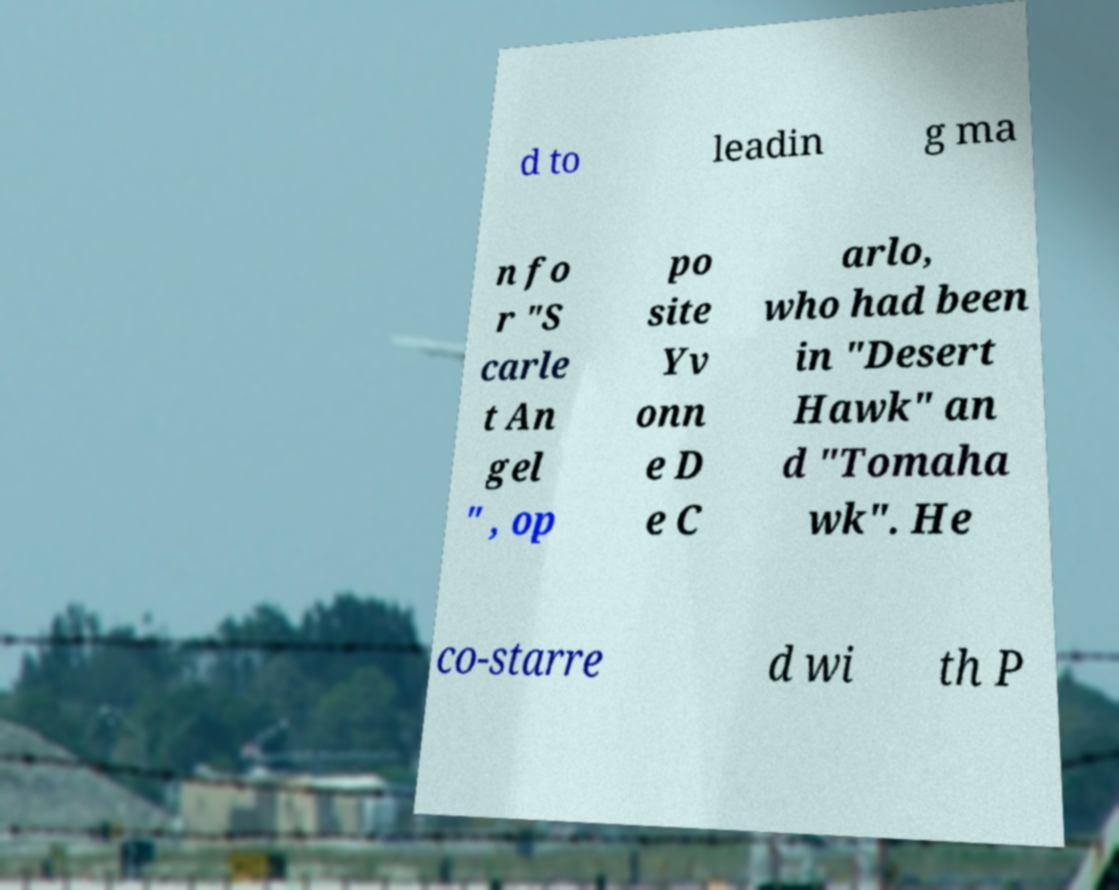Can you accurately transcribe the text from the provided image for me? d to leadin g ma n fo r "S carle t An gel " , op po site Yv onn e D e C arlo, who had been in "Desert Hawk" an d "Tomaha wk". He co-starre d wi th P 